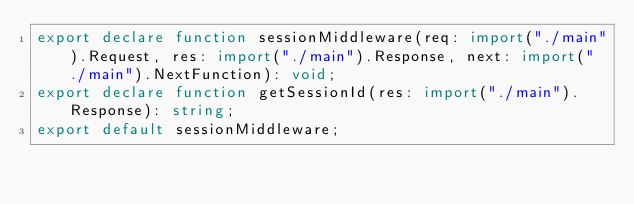Convert code to text. <code><loc_0><loc_0><loc_500><loc_500><_TypeScript_>export declare function sessionMiddleware(req: import("./main").Request, res: import("./main").Response, next: import("./main").NextFunction): void;
export declare function getSessionId(res: import("./main").Response): string;
export default sessionMiddleware;
</code> 